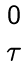Convert formula to latex. <formula><loc_0><loc_0><loc_500><loc_500>\begin{matrix} 0 \\ \tau \end{matrix}</formula> 